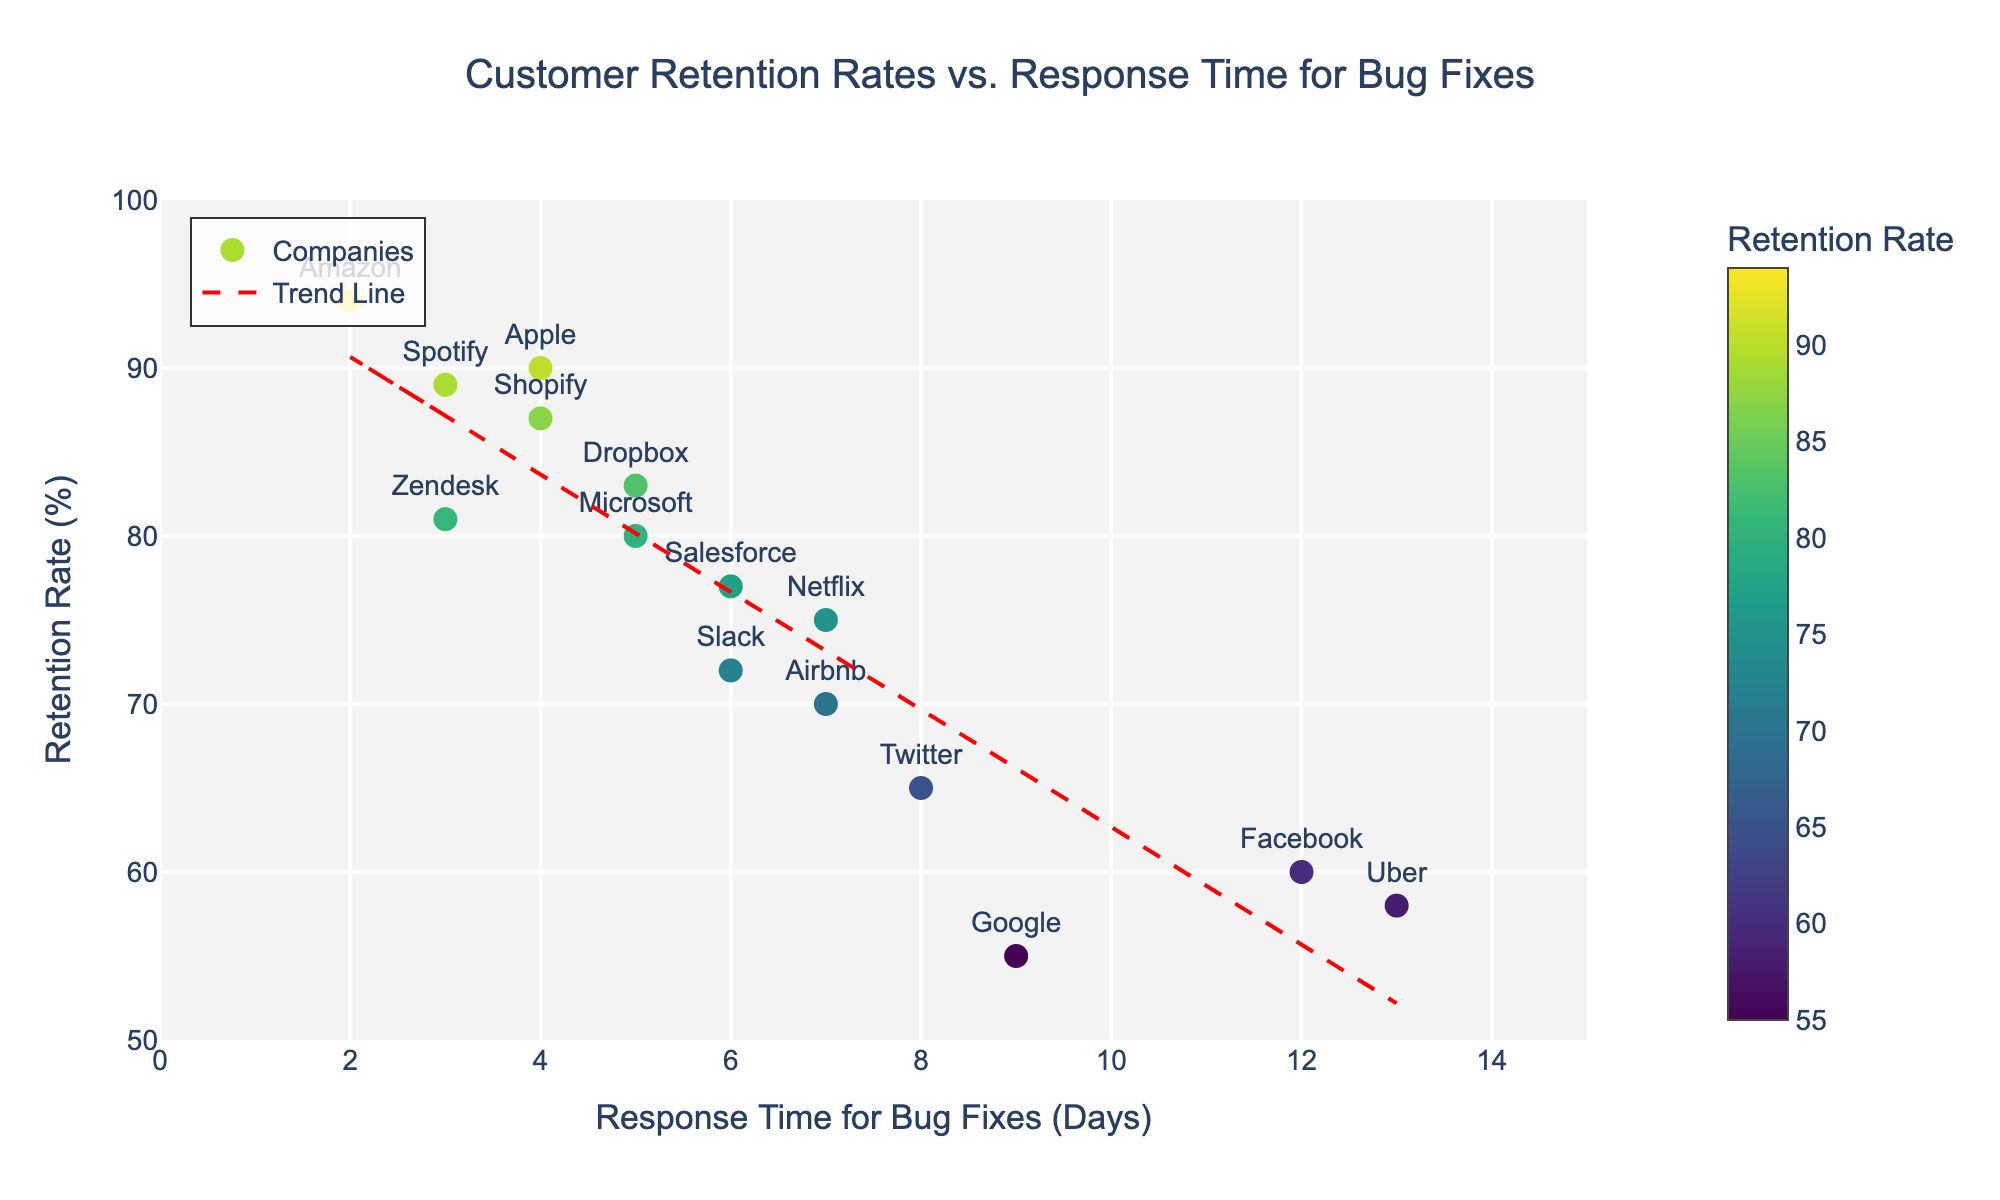What is the title of the scatter plot? The title of the scatter plot is prominently displayed at the top of the figure. It reads "Customer Retention Rates vs. Response Time for Bug Fixes".
Answer: Customer Retention Rates vs. Response Time for Bug Fixes What are the units on the x-axis? The x-axis label is "Response Time for Bug Fixes (Days)", indicating that the units for the x-axis are in days.
Answer: Days How many companies are displayed in the scatter plot? Each data point represents a company. Counting these data points in the scatter plot, there are 15 companies in total.
Answer: 15 Which company has the highest retention rate? By observing the plot, Amazon has the highest point on the y-axis at a retention rate of 94%.
Answer: Amazon What is the general trend indicated by the trend line? The trend line in the plot slopes downwards from left to right, indicating that as the response time for bug fixes increases, the customer retention rate tends to decrease.
Answer: Decreasing trend Are there any companies with a response time for bug fixes of 4 days? If so, which ones? By identifying the points on the x-axis at response time 4 days, Apple and Shopify are the companies located there.
Answer: Apple and Shopify What is the relationship between Netflix's response time for bug fixes and its retention rate? We locate Netflix on the plot, showing a response time of 7 days and a retention rate of 75%.
Answer: Response time: 7 days, Retention rate: 75% Compare the retention rates and response times of Google and Facebook. Google has a lower retention rate (55%) and a shorter response time (9 days) compared to Facebook, which has a retention rate of 60% and a response time of 12 days.
Answer: Google has a 55% retention rate and 9 days response time; Facebook has a 60% retention rate and 12 days response time Which company has the longest response time for bug fixes? The company with the highest value on the x-axis is Uber, with a response time of 13 days.
Answer: Uber What is the color gradient representing in the scatter plot? The color gradient is shown in the color bar and varies based on the retention rate, meaning the color of each marker corresponds to the company's retention rate.
Answer: Retention Rate 